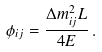<formula> <loc_0><loc_0><loc_500><loc_500>\phi _ { i j } = \frac { \Delta m ^ { 2 } _ { i j } L } { 4 E } \, .</formula> 